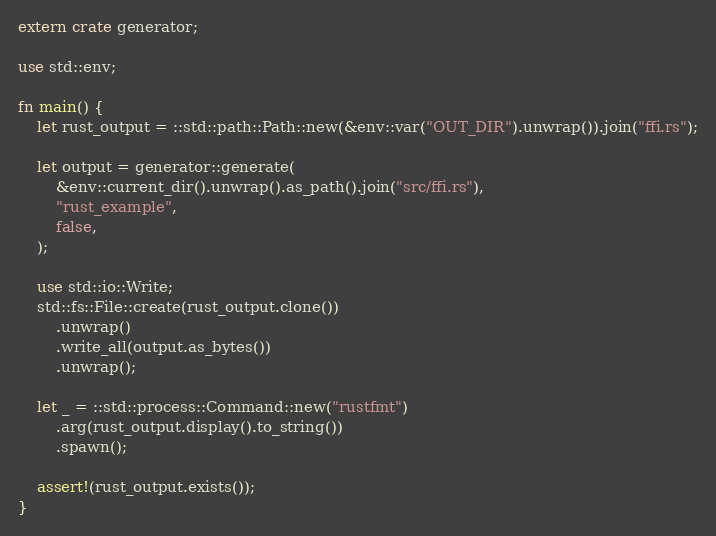Convert code to text. <code><loc_0><loc_0><loc_500><loc_500><_Rust_>extern crate generator;

use std::env;

fn main() {
    let rust_output = ::std::path::Path::new(&env::var("OUT_DIR").unwrap()).join("ffi.rs");

    let output = generator::generate(
        &env::current_dir().unwrap().as_path().join("src/ffi.rs"),
        "rust_example",
        false,
    );

    use std::io::Write;
    std::fs::File::create(rust_output.clone())
        .unwrap()
        .write_all(output.as_bytes())
        .unwrap();

    let _ = ::std::process::Command::new("rustfmt")
        .arg(rust_output.display().to_string())
        .spawn();

    assert!(rust_output.exists());
}
</code> 